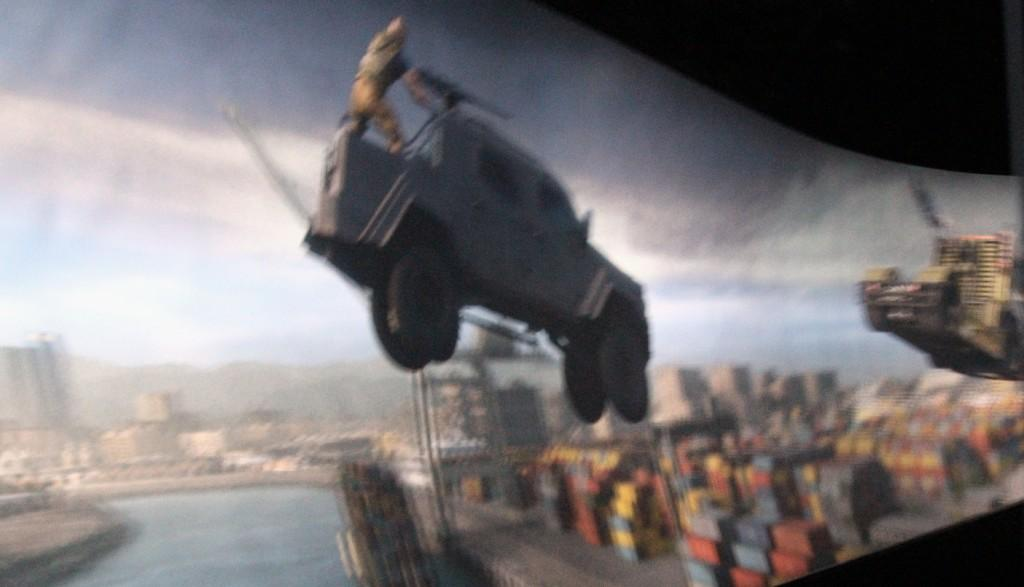What is the main subject of the image? The main subject of the image is a car. What is the car doing in the image? The car appears to be jumping in the image. Is there anyone on the car? Yes, there is a man standing on the car. What can be seen in the background of the image? There are buildings and a lake in the background of the image. How many docks are visible in the image? There are no docks present in the image. What type of man is standing on the car in the image? There is no specific type of man mentioned in the image; he is simply a man standing on the car. 